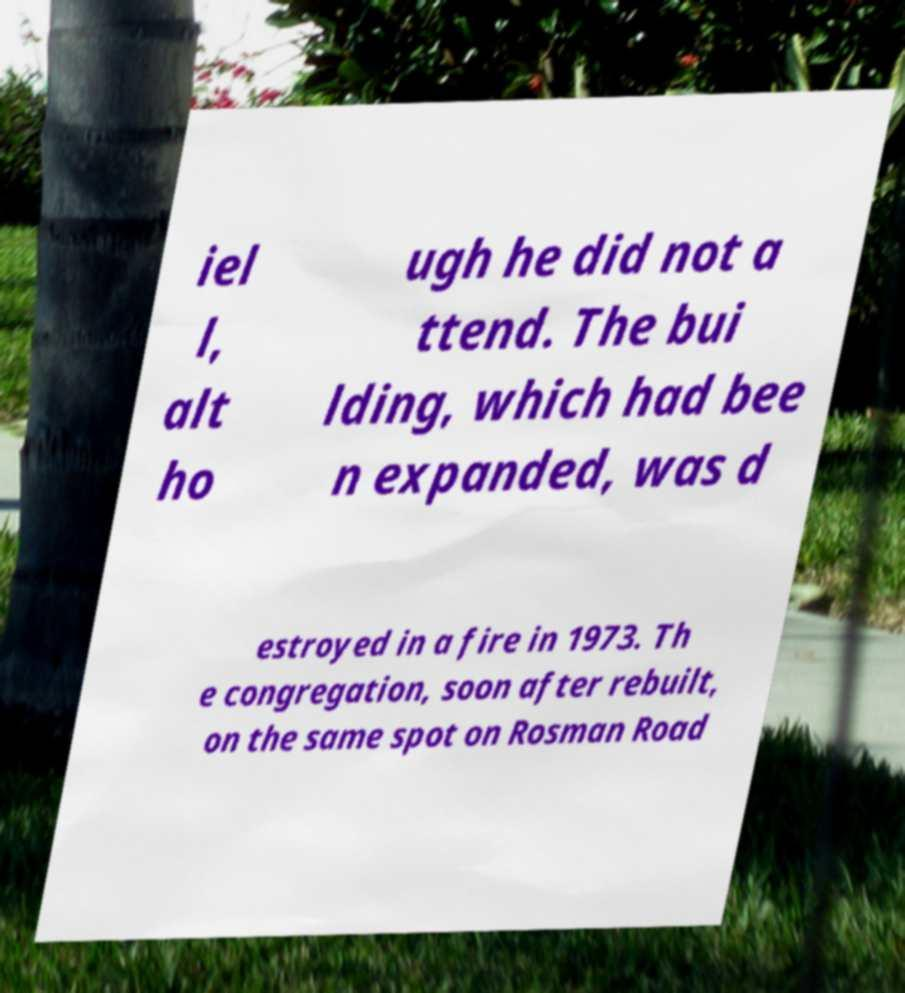Please read and relay the text visible in this image. What does it say? iel l, alt ho ugh he did not a ttend. The bui lding, which had bee n expanded, was d estroyed in a fire in 1973. Th e congregation, soon after rebuilt, on the same spot on Rosman Road 